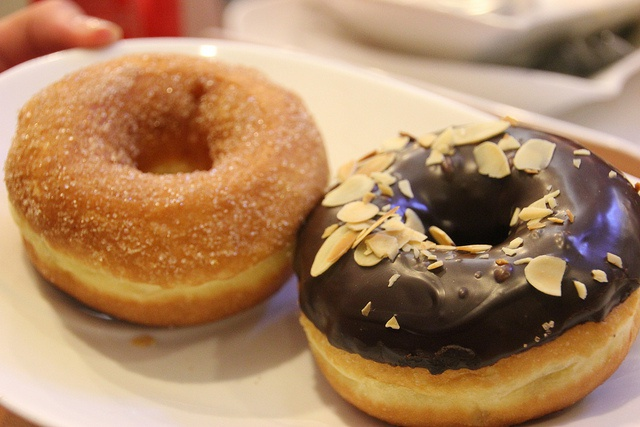Describe the objects in this image and their specific colors. I can see donut in gray, black, maroon, olive, and tan tones, donut in gray, red, tan, and maroon tones, and people in gray, salmon, brown, and tan tones in this image. 